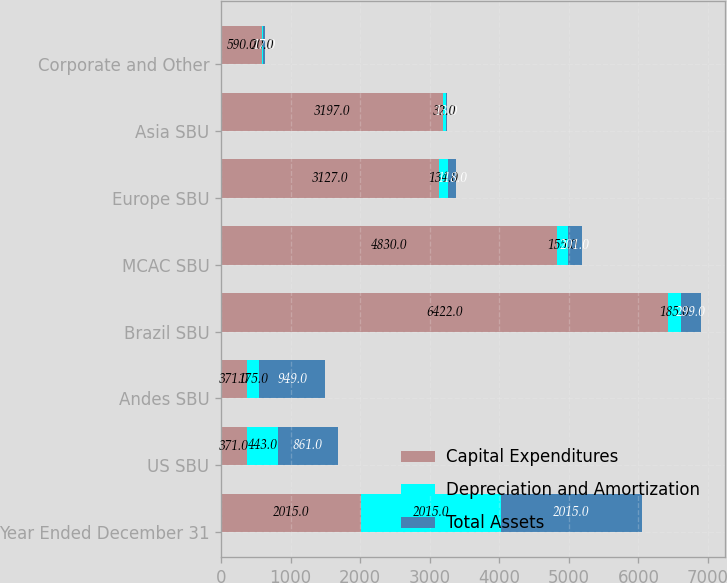<chart> <loc_0><loc_0><loc_500><loc_500><stacked_bar_chart><ecel><fcel>Year Ended December 31<fcel>US SBU<fcel>Andes SBU<fcel>Brazil SBU<fcel>MCAC SBU<fcel>Europe SBU<fcel>Asia SBU<fcel>Corporate and Other<nl><fcel>Capital Expenditures<fcel>2015<fcel>371<fcel>371<fcel>6422<fcel>4830<fcel>3127<fcel>3197<fcel>590<nl><fcel>Depreciation and Amortization<fcel>2015<fcel>443<fcel>175<fcel>185<fcel>155<fcel>134<fcel>32<fcel>20<nl><fcel>Total Assets<fcel>2015<fcel>861<fcel>949<fcel>299<fcel>201<fcel>118<fcel>13<fcel>17<nl></chart> 